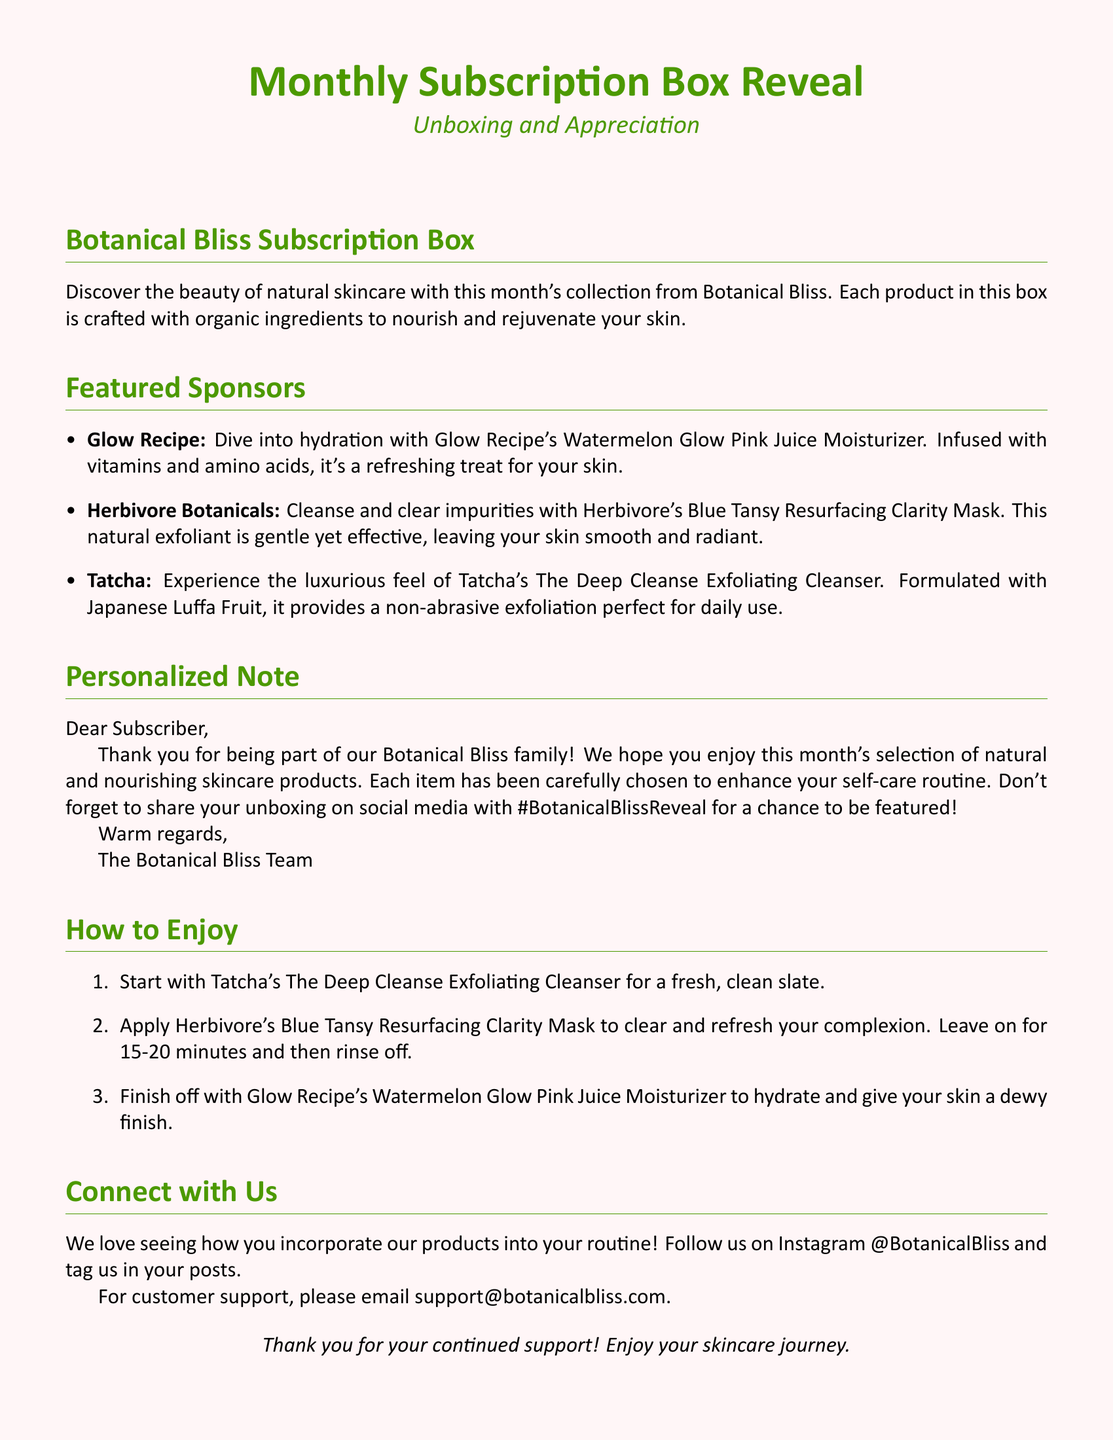What is the title of the document? The title of the document is prominently displayed at the beginning, "Monthly Subscription Box Reveal."
Answer: Monthly Subscription Box Reveal Who is the sponsor for the moisturizer included in the box? The document lists Glow Recipe as the sponsor for the Watermelon Glow Pink Juice Moisturizer.
Answer: Glow Recipe What type of mask is featured in this month's box? The document indicates that the mask included is Herbivore's Blue Tansy Resurfacing Clarity Mask.
Answer: Blue Tansy Resurfacing Clarity Mask How many steps are outlined in the 'How to Enjoy' section? The 'How to Enjoy' section contains three steps for using the products.
Answer: Three What social media hashtag is suggested for sharing the unboxing? The document provides the hashtag to use on social media as #BotanicalBlissReveal.
Answer: #BotanicalBlissReveal Who signed the personalized note? The personalized note is signed off by "The Botanical Bliss Team."
Answer: The Botanical Bliss Team What is the first product recommended to use in the routine? The first product mentioned in the routine is Tatcha's The Deep Cleanse Exfoliating Cleanser.
Answer: The Deep Cleanse Exfoliating Cleanser What color is the background of the document? The document describes the background color as a soft pink tint.
Answer: Soft pink What is the purpose of the 'Connect with Us' section? This section invites subscribers to follow on social media and provides customer support email information.
Answer: Follow on social media and customer support 